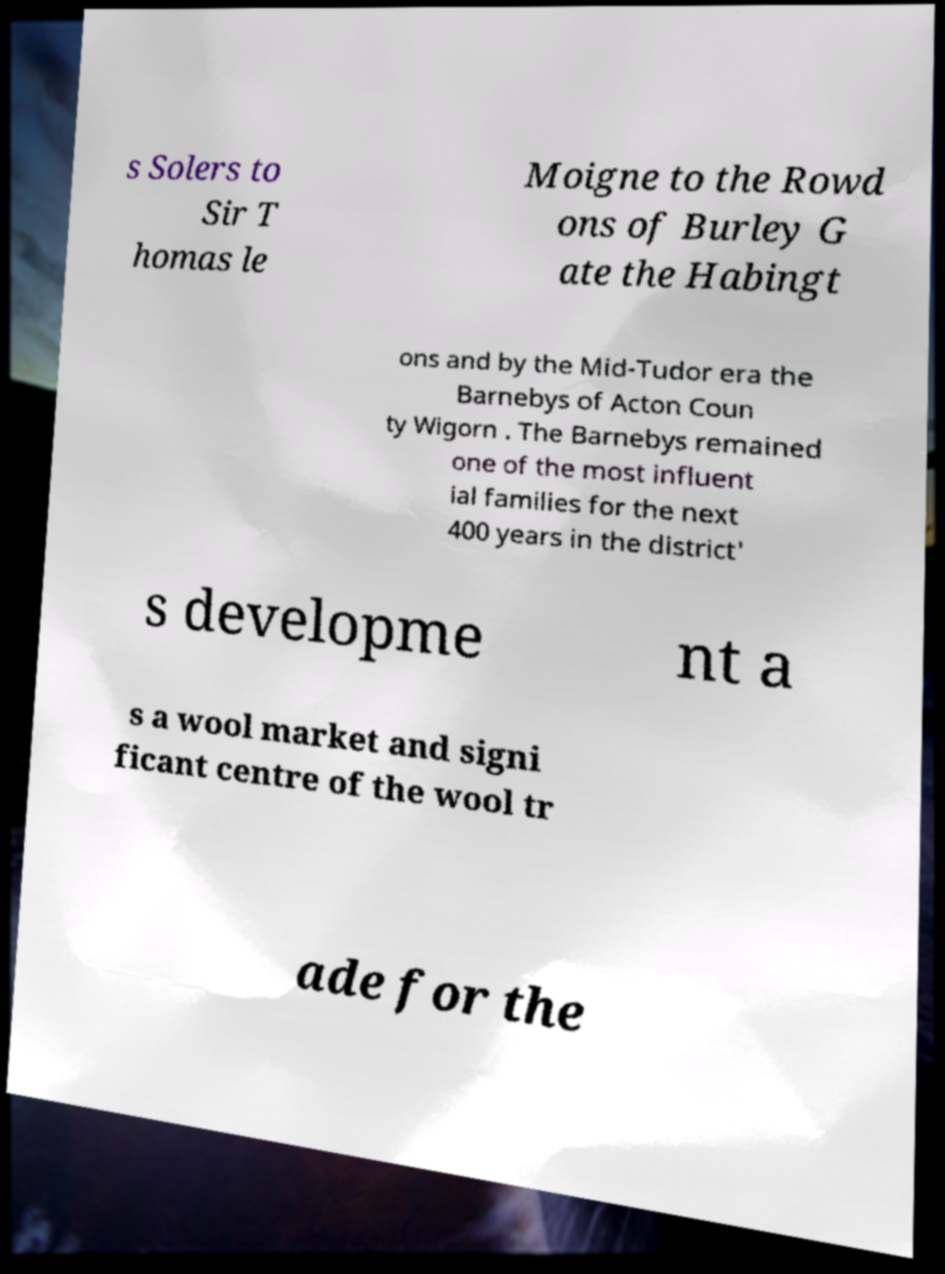What messages or text are displayed in this image? I need them in a readable, typed format. s Solers to Sir T homas le Moigne to the Rowd ons of Burley G ate the Habingt ons and by the Mid-Tudor era the Barnebys of Acton Coun ty Wigorn . The Barnebys remained one of the most influent ial families for the next 400 years in the district' s developme nt a s a wool market and signi ficant centre of the wool tr ade for the 